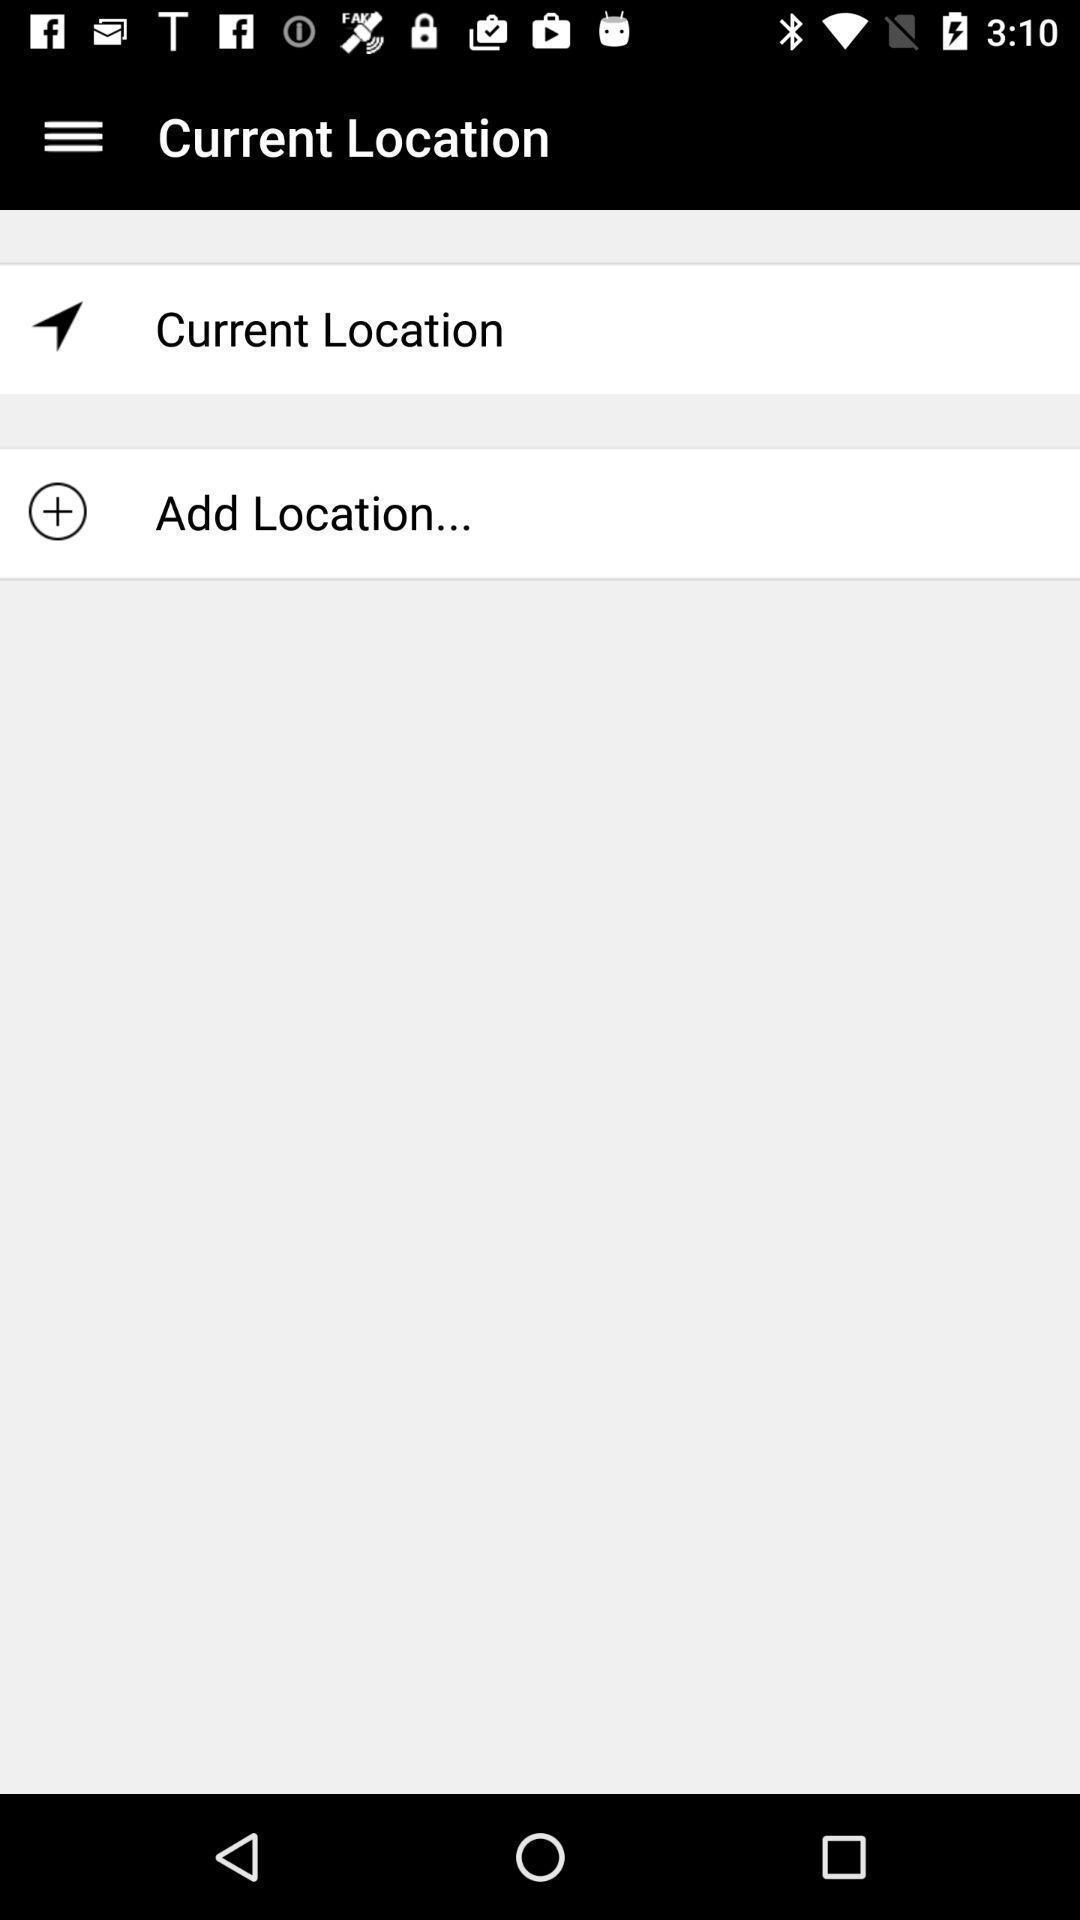Give me a summary of this screen capture. Page showing option like add location. 